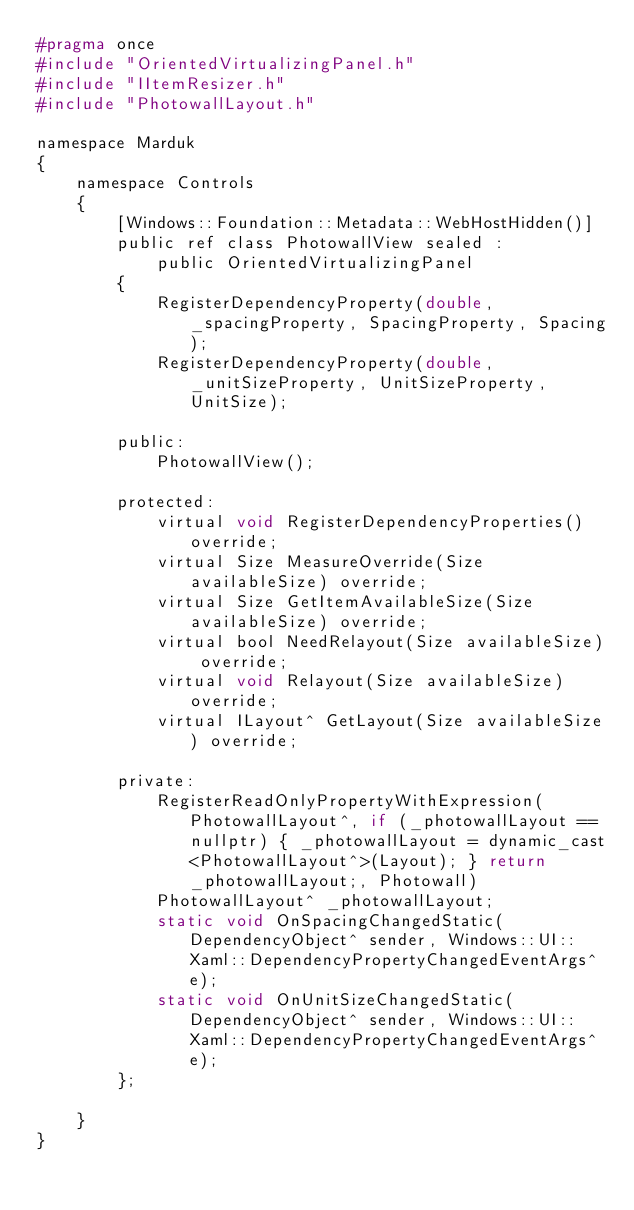Convert code to text. <code><loc_0><loc_0><loc_500><loc_500><_C_>#pragma once
#include "OrientedVirtualizingPanel.h"
#include "IItemResizer.h"
#include "PhotowallLayout.h"

namespace Marduk
{
    namespace Controls
    {
        [Windows::Foundation::Metadata::WebHostHidden()]
        public ref class PhotowallView sealed :
            public OrientedVirtualizingPanel
        {
            RegisterDependencyProperty(double, _spacingProperty, SpacingProperty, Spacing);
            RegisterDependencyProperty(double, _unitSizeProperty, UnitSizeProperty, UnitSize);

        public:
            PhotowallView();

        protected:
            virtual void RegisterDependencyProperties() override;
            virtual Size MeasureOverride(Size availableSize) override;
            virtual Size GetItemAvailableSize(Size availableSize) override;
            virtual bool NeedRelayout(Size availableSize) override;
            virtual void Relayout(Size availableSize) override;
            virtual ILayout^ GetLayout(Size availableSize) override;

        private:
            RegisterReadOnlyPropertyWithExpression(PhotowallLayout^, if (_photowallLayout == nullptr) { _photowallLayout = dynamic_cast<PhotowallLayout^>(Layout); } return _photowallLayout;, Photowall)
            PhotowallLayout^ _photowallLayout;
            static void OnSpacingChangedStatic(DependencyObject^ sender, Windows::UI::Xaml::DependencyPropertyChangedEventArgs^ e);
            static void OnUnitSizeChangedStatic(DependencyObject^ sender, Windows::UI::Xaml::DependencyPropertyChangedEventArgs^ e);
        };

    }
}</code> 